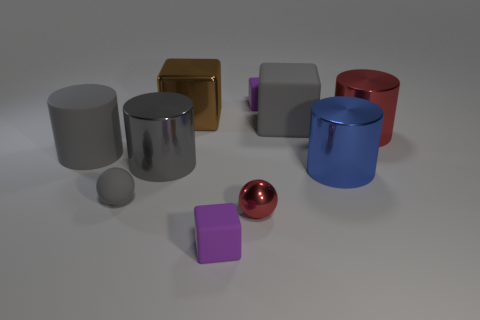Subtract 1 cubes. How many cubes are left? 3 Subtract all rubber blocks. How many blocks are left? 1 Subtract all yellow cubes. Subtract all purple cylinders. How many cubes are left? 4 Subtract all cylinders. How many objects are left? 6 Subtract all tiny yellow matte cubes. Subtract all small gray rubber spheres. How many objects are left? 9 Add 1 small matte objects. How many small matte objects are left? 4 Add 6 tiny metallic objects. How many tiny metallic objects exist? 7 Subtract 2 gray cylinders. How many objects are left? 8 